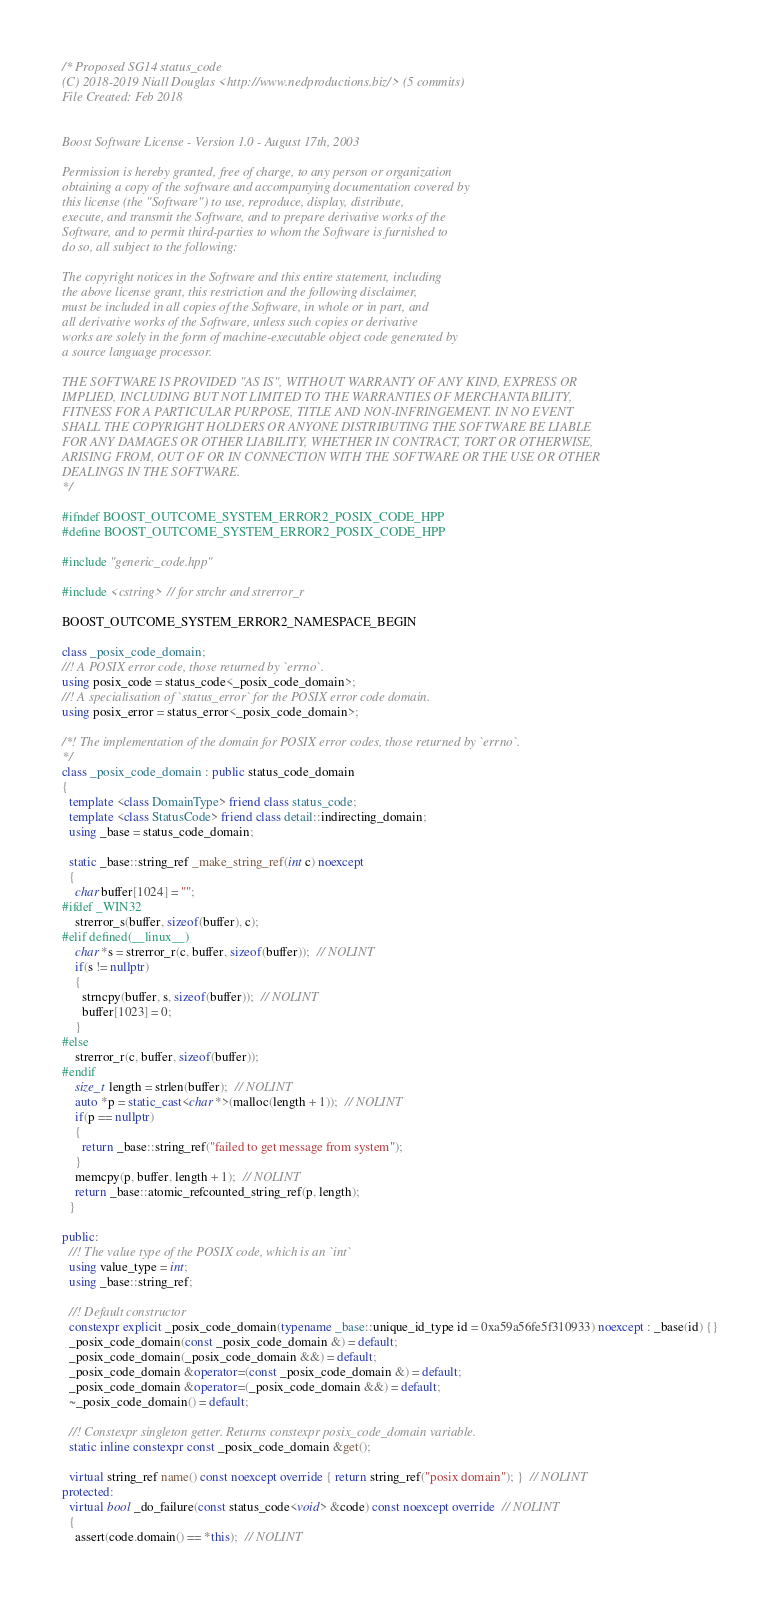<code> <loc_0><loc_0><loc_500><loc_500><_C++_>/* Proposed SG14 status_code
(C) 2018-2019 Niall Douglas <http://www.nedproductions.biz/> (5 commits)
File Created: Feb 2018


Boost Software License - Version 1.0 - August 17th, 2003

Permission is hereby granted, free of charge, to any person or organization
obtaining a copy of the software and accompanying documentation covered by
this license (the "Software") to use, reproduce, display, distribute,
execute, and transmit the Software, and to prepare derivative works of the
Software, and to permit third-parties to whom the Software is furnished to
do so, all subject to the following:

The copyright notices in the Software and this entire statement, including
the above license grant, this restriction and the following disclaimer,
must be included in all copies of the Software, in whole or in part, and
all derivative works of the Software, unless such copies or derivative
works are solely in the form of machine-executable object code generated by
a source language processor.

THE SOFTWARE IS PROVIDED "AS IS", WITHOUT WARRANTY OF ANY KIND, EXPRESS OR
IMPLIED, INCLUDING BUT NOT LIMITED TO THE WARRANTIES OF MERCHANTABILITY,
FITNESS FOR A PARTICULAR PURPOSE, TITLE AND NON-INFRINGEMENT. IN NO EVENT
SHALL THE COPYRIGHT HOLDERS OR ANYONE DISTRIBUTING THE SOFTWARE BE LIABLE
FOR ANY DAMAGES OR OTHER LIABILITY, WHETHER IN CONTRACT, TORT OR OTHERWISE,
ARISING FROM, OUT OF OR IN CONNECTION WITH THE SOFTWARE OR THE USE OR OTHER
DEALINGS IN THE SOFTWARE.
*/

#ifndef BOOST_OUTCOME_SYSTEM_ERROR2_POSIX_CODE_HPP
#define BOOST_OUTCOME_SYSTEM_ERROR2_POSIX_CODE_HPP

#include "generic_code.hpp"

#include <cstring>  // for strchr and strerror_r

BOOST_OUTCOME_SYSTEM_ERROR2_NAMESPACE_BEGIN

class _posix_code_domain;
//! A POSIX error code, those returned by `errno`.
using posix_code = status_code<_posix_code_domain>;
//! A specialisation of `status_error` for the POSIX error code domain.
using posix_error = status_error<_posix_code_domain>;

/*! The implementation of the domain for POSIX error codes, those returned by `errno`.
*/
class _posix_code_domain : public status_code_domain
{
  template <class DomainType> friend class status_code;
  template <class StatusCode> friend class detail::indirecting_domain;
  using _base = status_code_domain;

  static _base::string_ref _make_string_ref(int c) noexcept
  {
    char buffer[1024] = "";
#ifdef _WIN32
    strerror_s(buffer, sizeof(buffer), c);
#elif defined(__linux__)
    char *s = strerror_r(c, buffer, sizeof(buffer));  // NOLINT
    if(s != nullptr)
    {
      strncpy(buffer, s, sizeof(buffer));  // NOLINT
      buffer[1023] = 0;
    }
#else
    strerror_r(c, buffer, sizeof(buffer));
#endif
    size_t length = strlen(buffer);  // NOLINT
    auto *p = static_cast<char *>(malloc(length + 1));  // NOLINT
    if(p == nullptr)
    {
      return _base::string_ref("failed to get message from system");
    }
    memcpy(p, buffer, length + 1);  // NOLINT
    return _base::atomic_refcounted_string_ref(p, length);
  }

public:
  //! The value type of the POSIX code, which is an `int`
  using value_type = int;
  using _base::string_ref;

  //! Default constructor
  constexpr explicit _posix_code_domain(typename _base::unique_id_type id = 0xa59a56fe5f310933) noexcept : _base(id) {}
  _posix_code_domain(const _posix_code_domain &) = default;
  _posix_code_domain(_posix_code_domain &&) = default;
  _posix_code_domain &operator=(const _posix_code_domain &) = default;
  _posix_code_domain &operator=(_posix_code_domain &&) = default;
  ~_posix_code_domain() = default;

  //! Constexpr singleton getter. Returns constexpr posix_code_domain variable.
  static inline constexpr const _posix_code_domain &get();

  virtual string_ref name() const noexcept override { return string_ref("posix domain"); }  // NOLINT
protected:
  virtual bool _do_failure(const status_code<void> &code) const noexcept override  // NOLINT
  {
    assert(code.domain() == *this);  // NOLINT</code> 